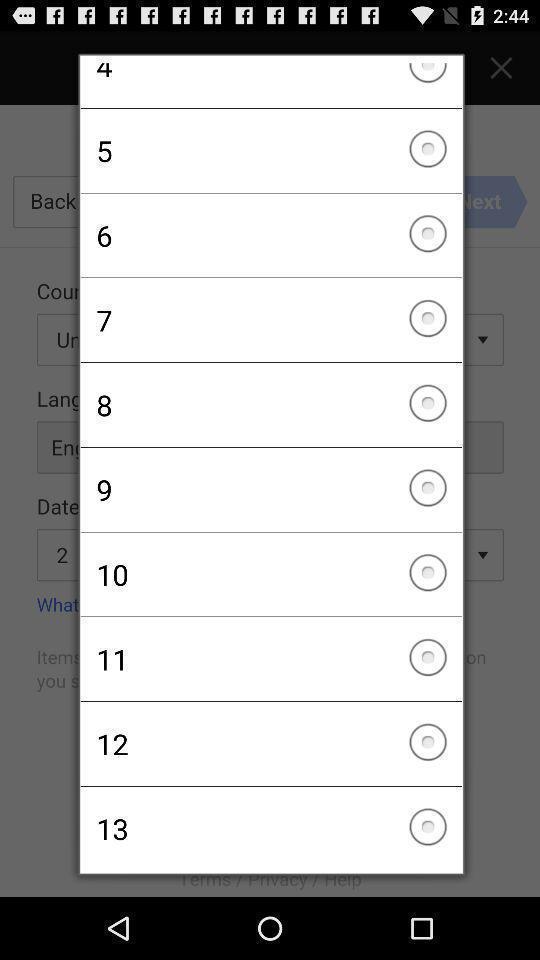Explain the elements present in this screenshot. Pop-up of numbers to select in a game app. 